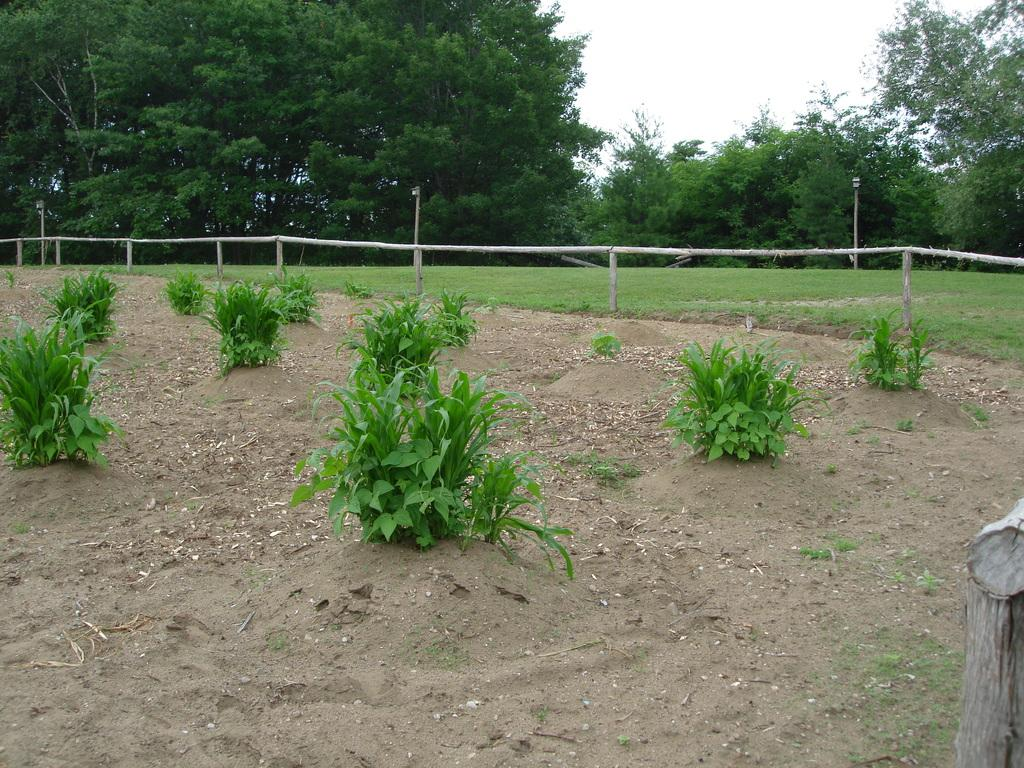What type of vegetation can be seen in the image? There are trees in the image. What structures are present in the image? There are poles and a fence in the image. What is on the ground in the image? There are shrubs on the ground in the image. What part of the natural environment is visible in the image? The sky is visible in the image. Can you see any suits hanging on the trees in the image? There are no suits present in the image; it features trees, poles, a fence, shrubs, and the sky. Are there any fangs visible on the shrubs in the image? There are no fangs present in the image; it features trees, poles, a fence, shrubs, and the sky. 